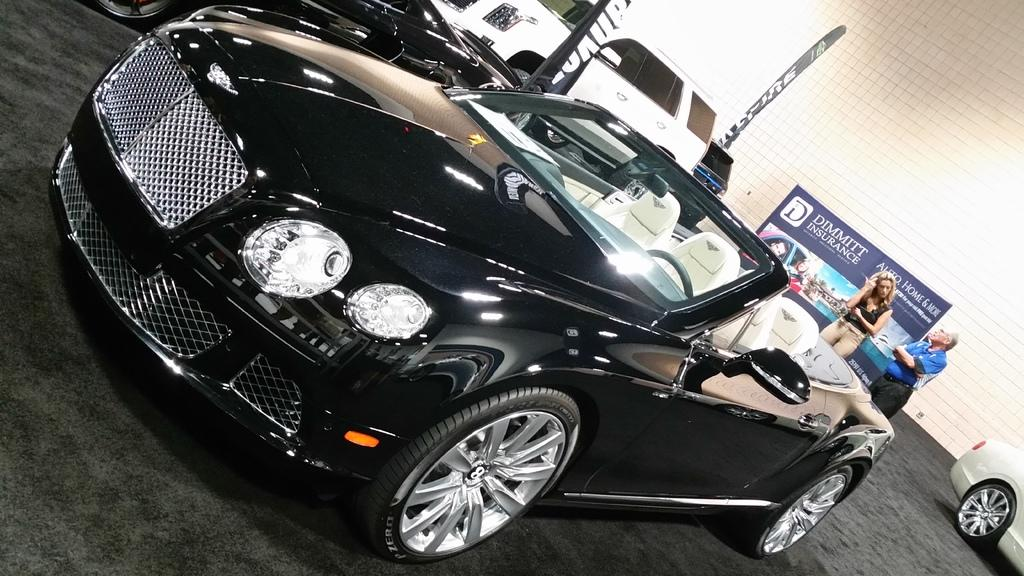What types of objects are present in the image? There are vehicles, a man, and a woman in the image. What can be seen in the background of the image? There is a poster and a wall in the background of the image. How many muscles can be seen on the poster in the image? There is no mention of muscles on the poster in the image, as it only states that there is a poster in the background. 